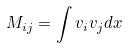Convert formula to latex. <formula><loc_0><loc_0><loc_500><loc_500>M _ { i j } = \int v _ { i } v _ { j } d x</formula> 